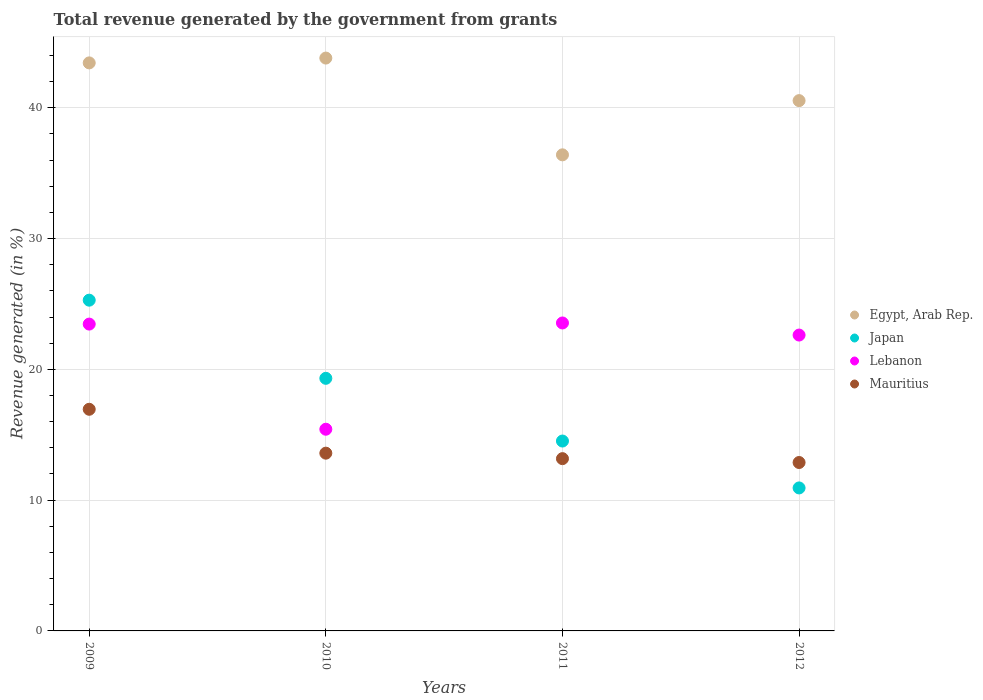What is the total revenue generated in Japan in 2009?
Your response must be concise. 25.29. Across all years, what is the maximum total revenue generated in Lebanon?
Give a very brief answer. 23.55. Across all years, what is the minimum total revenue generated in Japan?
Your response must be concise. 10.93. In which year was the total revenue generated in Mauritius maximum?
Your answer should be very brief. 2009. In which year was the total revenue generated in Lebanon minimum?
Offer a very short reply. 2010. What is the total total revenue generated in Lebanon in the graph?
Keep it short and to the point. 85.05. What is the difference between the total revenue generated in Lebanon in 2009 and that in 2010?
Offer a very short reply. 8.04. What is the difference between the total revenue generated in Egypt, Arab Rep. in 2011 and the total revenue generated in Lebanon in 2012?
Ensure brevity in your answer.  13.78. What is the average total revenue generated in Mauritius per year?
Ensure brevity in your answer.  14.15. In the year 2011, what is the difference between the total revenue generated in Mauritius and total revenue generated in Egypt, Arab Rep.?
Your answer should be very brief. -23.23. What is the ratio of the total revenue generated in Lebanon in 2010 to that in 2012?
Give a very brief answer. 0.68. Is the total revenue generated in Lebanon in 2009 less than that in 2010?
Make the answer very short. No. What is the difference between the highest and the second highest total revenue generated in Lebanon?
Keep it short and to the point. 0.09. What is the difference between the highest and the lowest total revenue generated in Egypt, Arab Rep.?
Offer a terse response. 7.4. In how many years, is the total revenue generated in Mauritius greater than the average total revenue generated in Mauritius taken over all years?
Give a very brief answer. 1. Is it the case that in every year, the sum of the total revenue generated in Egypt, Arab Rep. and total revenue generated in Japan  is greater than the sum of total revenue generated in Lebanon and total revenue generated in Mauritius?
Offer a very short reply. No. Is it the case that in every year, the sum of the total revenue generated in Lebanon and total revenue generated in Japan  is greater than the total revenue generated in Egypt, Arab Rep.?
Your answer should be very brief. No. Is the total revenue generated in Japan strictly greater than the total revenue generated in Lebanon over the years?
Ensure brevity in your answer.  No. How many years are there in the graph?
Offer a terse response. 4. What is the difference between two consecutive major ticks on the Y-axis?
Make the answer very short. 10. Does the graph contain any zero values?
Your response must be concise. No. How many legend labels are there?
Make the answer very short. 4. How are the legend labels stacked?
Offer a very short reply. Vertical. What is the title of the graph?
Keep it short and to the point. Total revenue generated by the government from grants. What is the label or title of the X-axis?
Make the answer very short. Years. What is the label or title of the Y-axis?
Give a very brief answer. Revenue generated (in %). What is the Revenue generated (in %) in Egypt, Arab Rep. in 2009?
Provide a short and direct response. 43.43. What is the Revenue generated (in %) of Japan in 2009?
Ensure brevity in your answer.  25.29. What is the Revenue generated (in %) in Lebanon in 2009?
Provide a short and direct response. 23.46. What is the Revenue generated (in %) of Mauritius in 2009?
Keep it short and to the point. 16.95. What is the Revenue generated (in %) of Egypt, Arab Rep. in 2010?
Your answer should be very brief. 43.8. What is the Revenue generated (in %) of Japan in 2010?
Provide a short and direct response. 19.31. What is the Revenue generated (in %) of Lebanon in 2010?
Keep it short and to the point. 15.42. What is the Revenue generated (in %) in Mauritius in 2010?
Your answer should be very brief. 13.59. What is the Revenue generated (in %) of Egypt, Arab Rep. in 2011?
Offer a very short reply. 36.4. What is the Revenue generated (in %) in Japan in 2011?
Your answer should be compact. 14.52. What is the Revenue generated (in %) of Lebanon in 2011?
Offer a very short reply. 23.55. What is the Revenue generated (in %) in Mauritius in 2011?
Your response must be concise. 13.17. What is the Revenue generated (in %) in Egypt, Arab Rep. in 2012?
Your response must be concise. 40.55. What is the Revenue generated (in %) in Japan in 2012?
Offer a very short reply. 10.93. What is the Revenue generated (in %) of Lebanon in 2012?
Your answer should be very brief. 22.62. What is the Revenue generated (in %) in Mauritius in 2012?
Ensure brevity in your answer.  12.88. Across all years, what is the maximum Revenue generated (in %) of Egypt, Arab Rep.?
Make the answer very short. 43.8. Across all years, what is the maximum Revenue generated (in %) in Japan?
Provide a succinct answer. 25.29. Across all years, what is the maximum Revenue generated (in %) in Lebanon?
Your answer should be compact. 23.55. Across all years, what is the maximum Revenue generated (in %) in Mauritius?
Provide a short and direct response. 16.95. Across all years, what is the minimum Revenue generated (in %) of Egypt, Arab Rep.?
Your answer should be very brief. 36.4. Across all years, what is the minimum Revenue generated (in %) in Japan?
Keep it short and to the point. 10.93. Across all years, what is the minimum Revenue generated (in %) of Lebanon?
Your answer should be very brief. 15.42. Across all years, what is the minimum Revenue generated (in %) in Mauritius?
Your response must be concise. 12.88. What is the total Revenue generated (in %) in Egypt, Arab Rep. in the graph?
Give a very brief answer. 164.18. What is the total Revenue generated (in %) in Japan in the graph?
Ensure brevity in your answer.  70.06. What is the total Revenue generated (in %) in Lebanon in the graph?
Offer a very short reply. 85.05. What is the total Revenue generated (in %) of Mauritius in the graph?
Keep it short and to the point. 56.59. What is the difference between the Revenue generated (in %) of Egypt, Arab Rep. in 2009 and that in 2010?
Your answer should be compact. -0.37. What is the difference between the Revenue generated (in %) of Japan in 2009 and that in 2010?
Your answer should be compact. 5.98. What is the difference between the Revenue generated (in %) of Lebanon in 2009 and that in 2010?
Your response must be concise. 8.04. What is the difference between the Revenue generated (in %) of Mauritius in 2009 and that in 2010?
Keep it short and to the point. 3.36. What is the difference between the Revenue generated (in %) in Egypt, Arab Rep. in 2009 and that in 2011?
Ensure brevity in your answer.  7.03. What is the difference between the Revenue generated (in %) of Japan in 2009 and that in 2011?
Provide a succinct answer. 10.77. What is the difference between the Revenue generated (in %) of Lebanon in 2009 and that in 2011?
Make the answer very short. -0.09. What is the difference between the Revenue generated (in %) of Mauritius in 2009 and that in 2011?
Your response must be concise. 3.77. What is the difference between the Revenue generated (in %) of Egypt, Arab Rep. in 2009 and that in 2012?
Offer a very short reply. 2.89. What is the difference between the Revenue generated (in %) of Japan in 2009 and that in 2012?
Offer a terse response. 14.36. What is the difference between the Revenue generated (in %) of Lebanon in 2009 and that in 2012?
Your answer should be very brief. 0.84. What is the difference between the Revenue generated (in %) of Mauritius in 2009 and that in 2012?
Give a very brief answer. 4.07. What is the difference between the Revenue generated (in %) of Egypt, Arab Rep. in 2010 and that in 2011?
Your answer should be compact. 7.4. What is the difference between the Revenue generated (in %) in Japan in 2010 and that in 2011?
Offer a very short reply. 4.8. What is the difference between the Revenue generated (in %) in Lebanon in 2010 and that in 2011?
Provide a short and direct response. -8.13. What is the difference between the Revenue generated (in %) in Mauritius in 2010 and that in 2011?
Ensure brevity in your answer.  0.42. What is the difference between the Revenue generated (in %) in Egypt, Arab Rep. in 2010 and that in 2012?
Make the answer very short. 3.25. What is the difference between the Revenue generated (in %) in Japan in 2010 and that in 2012?
Make the answer very short. 8.38. What is the difference between the Revenue generated (in %) in Lebanon in 2010 and that in 2012?
Provide a succinct answer. -7.2. What is the difference between the Revenue generated (in %) of Mauritius in 2010 and that in 2012?
Your answer should be very brief. 0.71. What is the difference between the Revenue generated (in %) in Egypt, Arab Rep. in 2011 and that in 2012?
Your answer should be compact. -4.15. What is the difference between the Revenue generated (in %) in Japan in 2011 and that in 2012?
Keep it short and to the point. 3.59. What is the difference between the Revenue generated (in %) in Lebanon in 2011 and that in 2012?
Your answer should be compact. 0.92. What is the difference between the Revenue generated (in %) of Mauritius in 2011 and that in 2012?
Ensure brevity in your answer.  0.29. What is the difference between the Revenue generated (in %) in Egypt, Arab Rep. in 2009 and the Revenue generated (in %) in Japan in 2010?
Make the answer very short. 24.12. What is the difference between the Revenue generated (in %) in Egypt, Arab Rep. in 2009 and the Revenue generated (in %) in Lebanon in 2010?
Make the answer very short. 28.01. What is the difference between the Revenue generated (in %) in Egypt, Arab Rep. in 2009 and the Revenue generated (in %) in Mauritius in 2010?
Your answer should be very brief. 29.84. What is the difference between the Revenue generated (in %) of Japan in 2009 and the Revenue generated (in %) of Lebanon in 2010?
Your answer should be very brief. 9.87. What is the difference between the Revenue generated (in %) in Japan in 2009 and the Revenue generated (in %) in Mauritius in 2010?
Provide a succinct answer. 11.7. What is the difference between the Revenue generated (in %) in Lebanon in 2009 and the Revenue generated (in %) in Mauritius in 2010?
Provide a short and direct response. 9.87. What is the difference between the Revenue generated (in %) of Egypt, Arab Rep. in 2009 and the Revenue generated (in %) of Japan in 2011?
Offer a terse response. 28.91. What is the difference between the Revenue generated (in %) in Egypt, Arab Rep. in 2009 and the Revenue generated (in %) in Lebanon in 2011?
Provide a short and direct response. 19.89. What is the difference between the Revenue generated (in %) of Egypt, Arab Rep. in 2009 and the Revenue generated (in %) of Mauritius in 2011?
Your answer should be very brief. 30.26. What is the difference between the Revenue generated (in %) of Japan in 2009 and the Revenue generated (in %) of Lebanon in 2011?
Offer a very short reply. 1.74. What is the difference between the Revenue generated (in %) of Japan in 2009 and the Revenue generated (in %) of Mauritius in 2011?
Give a very brief answer. 12.12. What is the difference between the Revenue generated (in %) in Lebanon in 2009 and the Revenue generated (in %) in Mauritius in 2011?
Ensure brevity in your answer.  10.29. What is the difference between the Revenue generated (in %) of Egypt, Arab Rep. in 2009 and the Revenue generated (in %) of Japan in 2012?
Provide a short and direct response. 32.5. What is the difference between the Revenue generated (in %) of Egypt, Arab Rep. in 2009 and the Revenue generated (in %) of Lebanon in 2012?
Give a very brief answer. 20.81. What is the difference between the Revenue generated (in %) in Egypt, Arab Rep. in 2009 and the Revenue generated (in %) in Mauritius in 2012?
Your answer should be very brief. 30.56. What is the difference between the Revenue generated (in %) in Japan in 2009 and the Revenue generated (in %) in Lebanon in 2012?
Offer a very short reply. 2.67. What is the difference between the Revenue generated (in %) of Japan in 2009 and the Revenue generated (in %) of Mauritius in 2012?
Provide a succinct answer. 12.41. What is the difference between the Revenue generated (in %) in Lebanon in 2009 and the Revenue generated (in %) in Mauritius in 2012?
Provide a short and direct response. 10.58. What is the difference between the Revenue generated (in %) in Egypt, Arab Rep. in 2010 and the Revenue generated (in %) in Japan in 2011?
Provide a succinct answer. 29.28. What is the difference between the Revenue generated (in %) of Egypt, Arab Rep. in 2010 and the Revenue generated (in %) of Lebanon in 2011?
Provide a short and direct response. 20.25. What is the difference between the Revenue generated (in %) in Egypt, Arab Rep. in 2010 and the Revenue generated (in %) in Mauritius in 2011?
Make the answer very short. 30.63. What is the difference between the Revenue generated (in %) in Japan in 2010 and the Revenue generated (in %) in Lebanon in 2011?
Your answer should be compact. -4.23. What is the difference between the Revenue generated (in %) in Japan in 2010 and the Revenue generated (in %) in Mauritius in 2011?
Your answer should be compact. 6.14. What is the difference between the Revenue generated (in %) in Lebanon in 2010 and the Revenue generated (in %) in Mauritius in 2011?
Make the answer very short. 2.25. What is the difference between the Revenue generated (in %) in Egypt, Arab Rep. in 2010 and the Revenue generated (in %) in Japan in 2012?
Ensure brevity in your answer.  32.87. What is the difference between the Revenue generated (in %) of Egypt, Arab Rep. in 2010 and the Revenue generated (in %) of Lebanon in 2012?
Provide a short and direct response. 21.18. What is the difference between the Revenue generated (in %) in Egypt, Arab Rep. in 2010 and the Revenue generated (in %) in Mauritius in 2012?
Your answer should be very brief. 30.92. What is the difference between the Revenue generated (in %) in Japan in 2010 and the Revenue generated (in %) in Lebanon in 2012?
Keep it short and to the point. -3.31. What is the difference between the Revenue generated (in %) in Japan in 2010 and the Revenue generated (in %) in Mauritius in 2012?
Offer a very short reply. 6.44. What is the difference between the Revenue generated (in %) in Lebanon in 2010 and the Revenue generated (in %) in Mauritius in 2012?
Make the answer very short. 2.54. What is the difference between the Revenue generated (in %) of Egypt, Arab Rep. in 2011 and the Revenue generated (in %) of Japan in 2012?
Offer a very short reply. 25.47. What is the difference between the Revenue generated (in %) in Egypt, Arab Rep. in 2011 and the Revenue generated (in %) in Lebanon in 2012?
Offer a very short reply. 13.78. What is the difference between the Revenue generated (in %) of Egypt, Arab Rep. in 2011 and the Revenue generated (in %) of Mauritius in 2012?
Offer a very short reply. 23.52. What is the difference between the Revenue generated (in %) in Japan in 2011 and the Revenue generated (in %) in Lebanon in 2012?
Make the answer very short. -8.1. What is the difference between the Revenue generated (in %) of Japan in 2011 and the Revenue generated (in %) of Mauritius in 2012?
Your response must be concise. 1.64. What is the difference between the Revenue generated (in %) in Lebanon in 2011 and the Revenue generated (in %) in Mauritius in 2012?
Provide a succinct answer. 10.67. What is the average Revenue generated (in %) in Egypt, Arab Rep. per year?
Offer a very short reply. 41.05. What is the average Revenue generated (in %) of Japan per year?
Keep it short and to the point. 17.51. What is the average Revenue generated (in %) of Lebanon per year?
Offer a terse response. 21.26. What is the average Revenue generated (in %) of Mauritius per year?
Provide a short and direct response. 14.15. In the year 2009, what is the difference between the Revenue generated (in %) in Egypt, Arab Rep. and Revenue generated (in %) in Japan?
Your answer should be very brief. 18.14. In the year 2009, what is the difference between the Revenue generated (in %) of Egypt, Arab Rep. and Revenue generated (in %) of Lebanon?
Make the answer very short. 19.97. In the year 2009, what is the difference between the Revenue generated (in %) of Egypt, Arab Rep. and Revenue generated (in %) of Mauritius?
Offer a very short reply. 26.49. In the year 2009, what is the difference between the Revenue generated (in %) in Japan and Revenue generated (in %) in Lebanon?
Ensure brevity in your answer.  1.83. In the year 2009, what is the difference between the Revenue generated (in %) of Japan and Revenue generated (in %) of Mauritius?
Your response must be concise. 8.34. In the year 2009, what is the difference between the Revenue generated (in %) in Lebanon and Revenue generated (in %) in Mauritius?
Your answer should be compact. 6.51. In the year 2010, what is the difference between the Revenue generated (in %) of Egypt, Arab Rep. and Revenue generated (in %) of Japan?
Keep it short and to the point. 24.49. In the year 2010, what is the difference between the Revenue generated (in %) of Egypt, Arab Rep. and Revenue generated (in %) of Lebanon?
Your answer should be compact. 28.38. In the year 2010, what is the difference between the Revenue generated (in %) in Egypt, Arab Rep. and Revenue generated (in %) in Mauritius?
Offer a very short reply. 30.21. In the year 2010, what is the difference between the Revenue generated (in %) in Japan and Revenue generated (in %) in Lebanon?
Make the answer very short. 3.89. In the year 2010, what is the difference between the Revenue generated (in %) of Japan and Revenue generated (in %) of Mauritius?
Offer a terse response. 5.72. In the year 2010, what is the difference between the Revenue generated (in %) in Lebanon and Revenue generated (in %) in Mauritius?
Ensure brevity in your answer.  1.83. In the year 2011, what is the difference between the Revenue generated (in %) of Egypt, Arab Rep. and Revenue generated (in %) of Japan?
Your answer should be compact. 21.88. In the year 2011, what is the difference between the Revenue generated (in %) of Egypt, Arab Rep. and Revenue generated (in %) of Lebanon?
Provide a succinct answer. 12.86. In the year 2011, what is the difference between the Revenue generated (in %) of Egypt, Arab Rep. and Revenue generated (in %) of Mauritius?
Offer a very short reply. 23.23. In the year 2011, what is the difference between the Revenue generated (in %) of Japan and Revenue generated (in %) of Lebanon?
Keep it short and to the point. -9.03. In the year 2011, what is the difference between the Revenue generated (in %) in Japan and Revenue generated (in %) in Mauritius?
Provide a short and direct response. 1.35. In the year 2011, what is the difference between the Revenue generated (in %) of Lebanon and Revenue generated (in %) of Mauritius?
Your response must be concise. 10.37. In the year 2012, what is the difference between the Revenue generated (in %) of Egypt, Arab Rep. and Revenue generated (in %) of Japan?
Offer a very short reply. 29.61. In the year 2012, what is the difference between the Revenue generated (in %) of Egypt, Arab Rep. and Revenue generated (in %) of Lebanon?
Keep it short and to the point. 17.93. In the year 2012, what is the difference between the Revenue generated (in %) in Egypt, Arab Rep. and Revenue generated (in %) in Mauritius?
Provide a succinct answer. 27.67. In the year 2012, what is the difference between the Revenue generated (in %) of Japan and Revenue generated (in %) of Lebanon?
Provide a short and direct response. -11.69. In the year 2012, what is the difference between the Revenue generated (in %) in Japan and Revenue generated (in %) in Mauritius?
Ensure brevity in your answer.  -1.94. In the year 2012, what is the difference between the Revenue generated (in %) in Lebanon and Revenue generated (in %) in Mauritius?
Your response must be concise. 9.74. What is the ratio of the Revenue generated (in %) of Egypt, Arab Rep. in 2009 to that in 2010?
Offer a terse response. 0.99. What is the ratio of the Revenue generated (in %) of Japan in 2009 to that in 2010?
Offer a very short reply. 1.31. What is the ratio of the Revenue generated (in %) of Lebanon in 2009 to that in 2010?
Ensure brevity in your answer.  1.52. What is the ratio of the Revenue generated (in %) of Mauritius in 2009 to that in 2010?
Ensure brevity in your answer.  1.25. What is the ratio of the Revenue generated (in %) in Egypt, Arab Rep. in 2009 to that in 2011?
Make the answer very short. 1.19. What is the ratio of the Revenue generated (in %) of Japan in 2009 to that in 2011?
Your answer should be very brief. 1.74. What is the ratio of the Revenue generated (in %) of Mauritius in 2009 to that in 2011?
Offer a very short reply. 1.29. What is the ratio of the Revenue generated (in %) of Egypt, Arab Rep. in 2009 to that in 2012?
Offer a terse response. 1.07. What is the ratio of the Revenue generated (in %) of Japan in 2009 to that in 2012?
Make the answer very short. 2.31. What is the ratio of the Revenue generated (in %) in Lebanon in 2009 to that in 2012?
Provide a short and direct response. 1.04. What is the ratio of the Revenue generated (in %) of Mauritius in 2009 to that in 2012?
Provide a succinct answer. 1.32. What is the ratio of the Revenue generated (in %) of Egypt, Arab Rep. in 2010 to that in 2011?
Give a very brief answer. 1.2. What is the ratio of the Revenue generated (in %) in Japan in 2010 to that in 2011?
Provide a short and direct response. 1.33. What is the ratio of the Revenue generated (in %) of Lebanon in 2010 to that in 2011?
Give a very brief answer. 0.65. What is the ratio of the Revenue generated (in %) in Mauritius in 2010 to that in 2011?
Provide a succinct answer. 1.03. What is the ratio of the Revenue generated (in %) of Egypt, Arab Rep. in 2010 to that in 2012?
Provide a succinct answer. 1.08. What is the ratio of the Revenue generated (in %) in Japan in 2010 to that in 2012?
Make the answer very short. 1.77. What is the ratio of the Revenue generated (in %) in Lebanon in 2010 to that in 2012?
Make the answer very short. 0.68. What is the ratio of the Revenue generated (in %) of Mauritius in 2010 to that in 2012?
Your response must be concise. 1.06. What is the ratio of the Revenue generated (in %) in Egypt, Arab Rep. in 2011 to that in 2012?
Keep it short and to the point. 0.9. What is the ratio of the Revenue generated (in %) in Japan in 2011 to that in 2012?
Make the answer very short. 1.33. What is the ratio of the Revenue generated (in %) in Lebanon in 2011 to that in 2012?
Make the answer very short. 1.04. What is the ratio of the Revenue generated (in %) of Mauritius in 2011 to that in 2012?
Your response must be concise. 1.02. What is the difference between the highest and the second highest Revenue generated (in %) in Egypt, Arab Rep.?
Offer a terse response. 0.37. What is the difference between the highest and the second highest Revenue generated (in %) in Japan?
Offer a terse response. 5.98. What is the difference between the highest and the second highest Revenue generated (in %) of Lebanon?
Provide a short and direct response. 0.09. What is the difference between the highest and the second highest Revenue generated (in %) of Mauritius?
Keep it short and to the point. 3.36. What is the difference between the highest and the lowest Revenue generated (in %) of Egypt, Arab Rep.?
Your answer should be very brief. 7.4. What is the difference between the highest and the lowest Revenue generated (in %) of Japan?
Give a very brief answer. 14.36. What is the difference between the highest and the lowest Revenue generated (in %) of Lebanon?
Make the answer very short. 8.13. What is the difference between the highest and the lowest Revenue generated (in %) of Mauritius?
Keep it short and to the point. 4.07. 